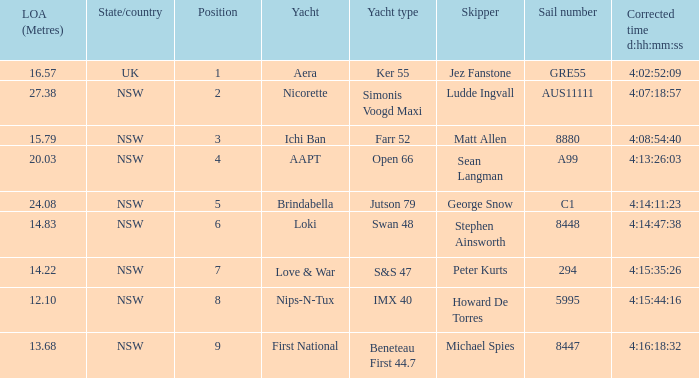What is the number of the sail with an overall length of 13.68? 8447.0. 